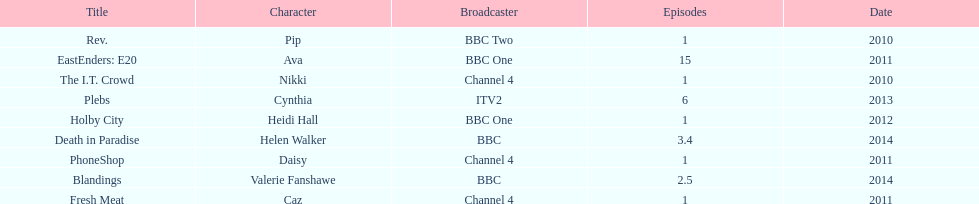What is the total number of shows sophie colguhoun appeared in? 9. 